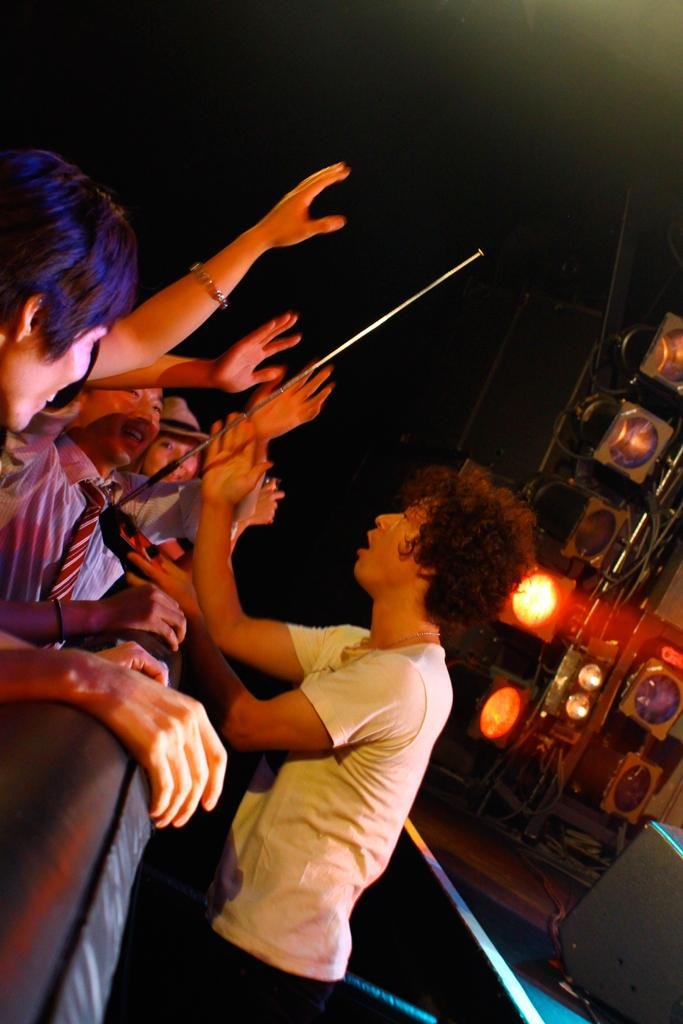How many people are in the image? There are people in the image, but the exact number is not specified. What is one of the people holding? One of the people is holding a stick. What can be seen in the image that provides illumination? There are lights visible in the image. What is present on the ground in the image? There are wires on the ground in the image. What type of stew is being prepared by the people in the image? There is no indication in the image that the people are preparing or cooking any type of stew. How many times have the people in the image folded their arms? The image does not show the people folding their arms, so it is impossible to determine how many times they have done so. 